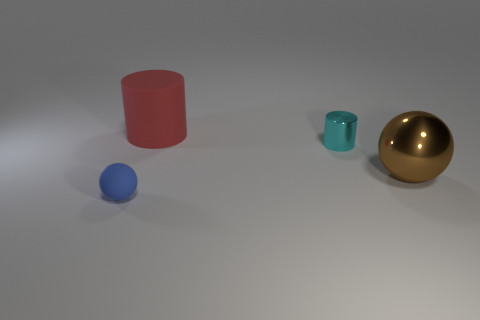What is the small cylinder made of?
Make the answer very short. Metal. There is another matte object that is the same shape as the small cyan thing; what size is it?
Provide a short and direct response. Large. What number of other objects are the same material as the red object?
Ensure brevity in your answer.  1. Does the tiny cylinder have the same material as the sphere that is in front of the big brown metallic object?
Your answer should be compact. No. Are there fewer big metal spheres that are in front of the blue matte ball than objects to the left of the cyan cylinder?
Offer a very short reply. Yes. What is the color of the rubber object that is behind the big brown metal object?
Your answer should be compact. Red. How many other things are there of the same color as the tiny matte thing?
Provide a succinct answer. 0. There is a sphere that is to the right of the red rubber cylinder; is it the same size as the tiny blue ball?
Your answer should be very brief. No. There is a large matte cylinder; what number of big red cylinders are left of it?
Offer a terse response. 0. Is there a brown thing that has the same size as the red object?
Keep it short and to the point. Yes. 